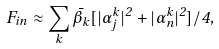<formula> <loc_0><loc_0><loc_500><loc_500>F _ { i n } \approx \sum _ { k } \bar { \beta } _ { k } [ | \alpha _ { j } ^ { k } | ^ { 2 } + | \alpha _ { n } ^ { k } | ^ { 2 } ] / 4 ,</formula> 